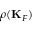Convert formula to latex. <formula><loc_0><loc_0><loc_500><loc_500>\rho ( { K } _ { F } )</formula> 